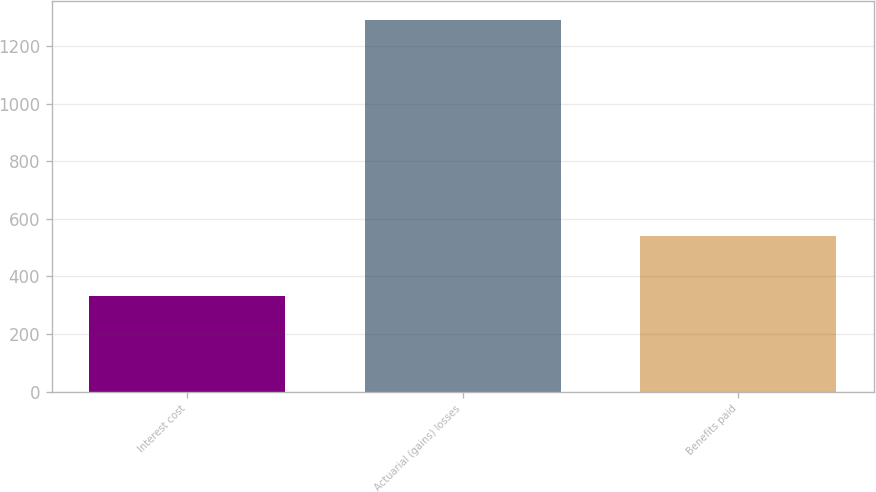Convert chart. <chart><loc_0><loc_0><loc_500><loc_500><bar_chart><fcel>Interest cost<fcel>Actuarial (gains) losses<fcel>Benefits paid<nl><fcel>333<fcel>1292<fcel>542<nl></chart> 